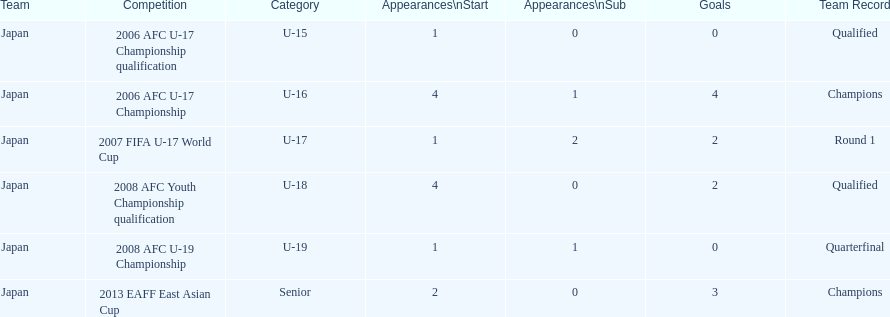Which tournament had the maximum number of initiations and targets? 2006 AFC U-17 Championship. 